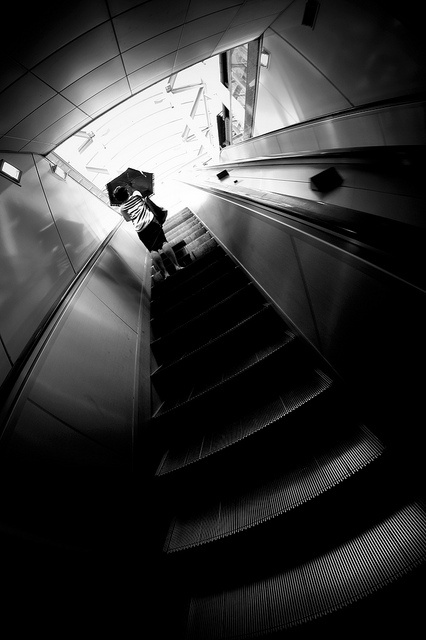Describe the objects in this image and their specific colors. I can see people in black, gray, white, and darkgray tones and umbrella in black, gray, lightgray, and darkgray tones in this image. 